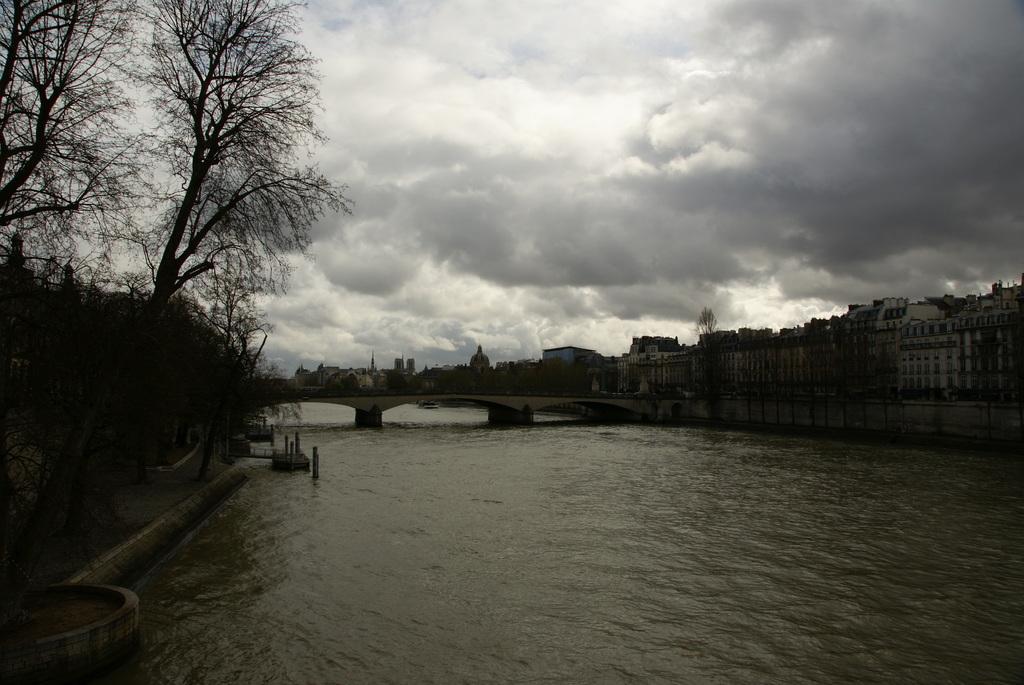Describe this image in one or two sentences. In this image we can see the bridge, water, trees, buildings with windows and we can also see the sky. 